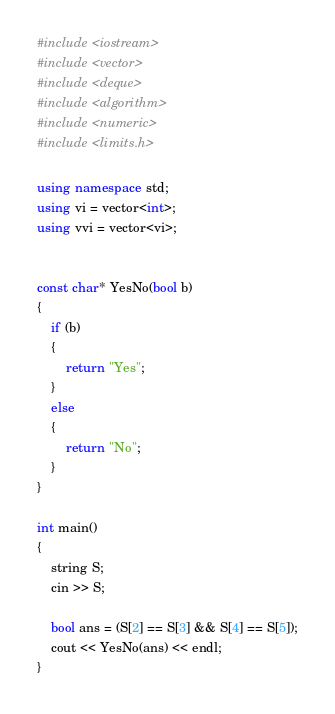Convert code to text. <code><loc_0><loc_0><loc_500><loc_500><_C++_>#include <iostream>
#include <vector>
#include <deque>
#include <algorithm>
#include <numeric>
#include <limits.h>

using namespace std;
using vi = vector<int>;
using vvi = vector<vi>;


const char* YesNo(bool b)
{
	if (b)
	{
		return "Yes";
	}
	else
	{
		return "No";
	}
}

int main()
{
	string S;
	cin >> S;

	bool ans = (S[2] == S[3] && S[4] == S[5]);
	cout << YesNo(ans) << endl;
}</code> 